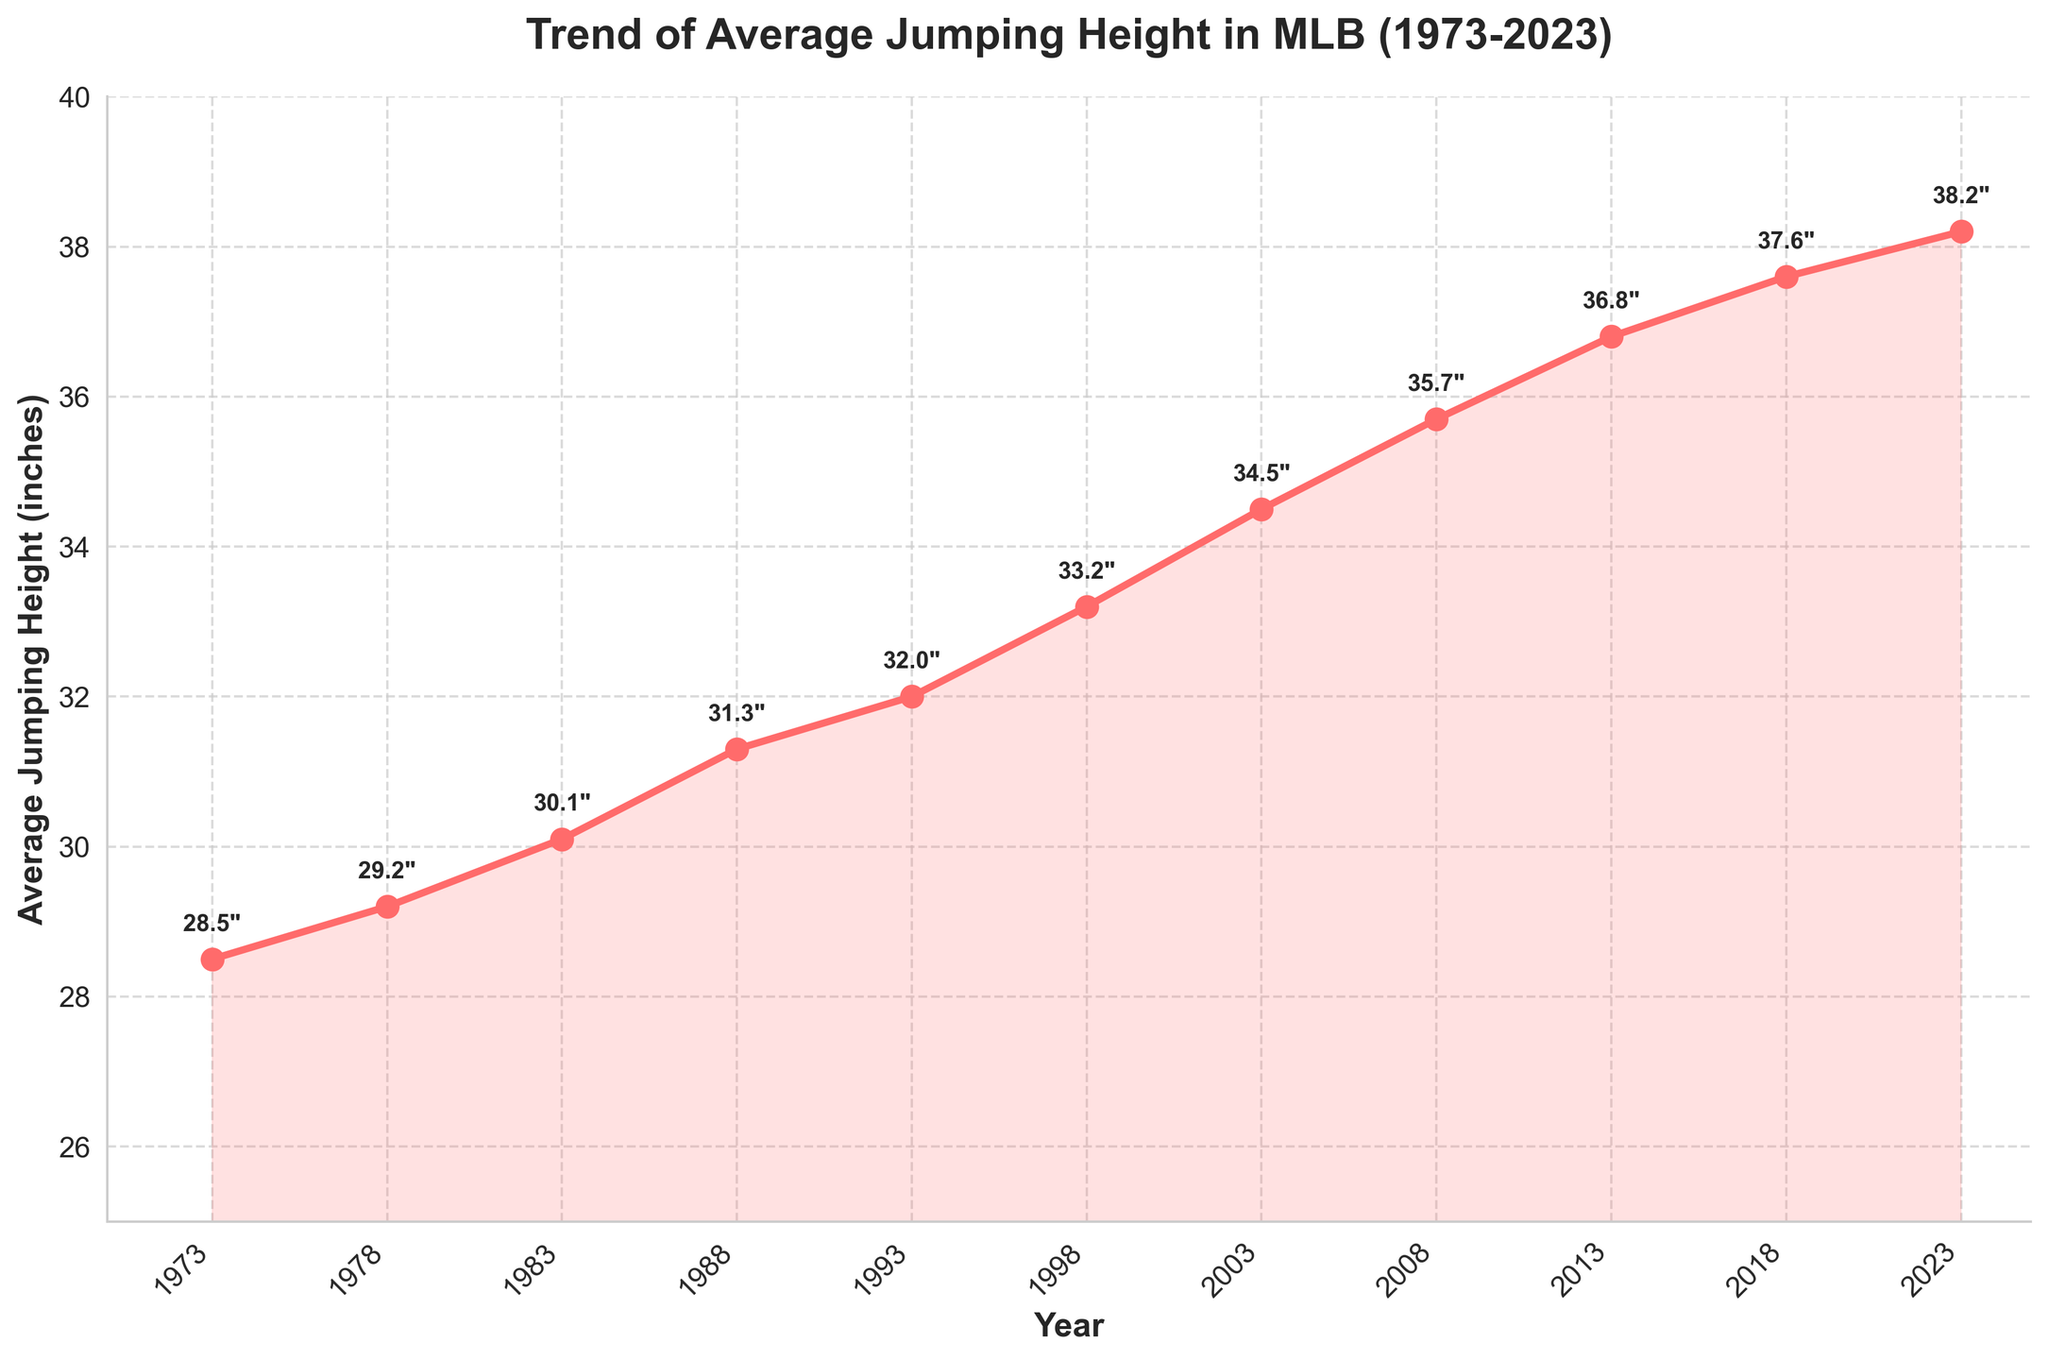What is the overall trend of average jumping height in MLB over the past 50 years? The figure shows a line chart with an increasing trend of average jumping height from 28.5 inches in 1973 to 38.2 inches in 2023, indicating an upward trend over the 50-year period.
Answer: Upward trend Identify the year when the average jumping height surpassed 35 inches for the first time. Referring to the line chart, the average jumping height surpassed 35 inches in 2008 for the first time, as indicated by both the plotted line and the annotation.
Answer: 2008 Calculate the total increase in average jumping height from 1973 to 2023. The average jumping height increased from 28.5 inches in 1973 to 38.2 inches in 2023. Subtracting the initial value from the final value: 38.2 - 28.5 = 9.7 inches.
Answer: 9.7 inches Which decade saw the greatest increase in average jumping height? Observing each decade interval, the 2003-2013 period shows the largest increase from 34.5 inches in 2003 to 36.8 inches in 2013, which is an increase of 2.3 inches.
Answer: 2003-2013 Compare the average jumping height in 1988 to the height in 2018. How much did it increase? The average jumping height in 1988 was 31.3 inches, and in 2018 it was 37.6 inches. Therefore, the increase is 37.6 - 31.3 = 6.3 inches.
Answer: 6.3 inches Identify any year where the average jumping height was at its minimum. The minimum average jumping height was recorded in 1973 at 28.5 inches, as observed at the start of the plotted data.
Answer: 1973 Estimate the slope of the average jumping height trend from 2008 to 2023. The slope can be estimated by finding the difference in heights and dividing by the difference in years: (38.2 - 35.7) / (2023 - 2008) = 2.5 / 15 ≈ 0.167 inches per year.
Answer: 0.167 inches/year What visual feature indicates the fluctuations in the data over the years? The marker 'dots' and the filled area under the line chart indicate data fluctuations over the years, showcasing exact values and the span of height variations respectively.
Answer: Marker 'dots' and filled area Calculate the average jumping height for the years 1993, 1998, and 2003. Sum the average heights for the years 1993 (32.0), 1998 (33.2), and 2003 (34.5) and then divide by the number of years: (32.0 + 33.2 + 34.5) / 3 = 33.23 inches.
Answer: 33.23 inches 